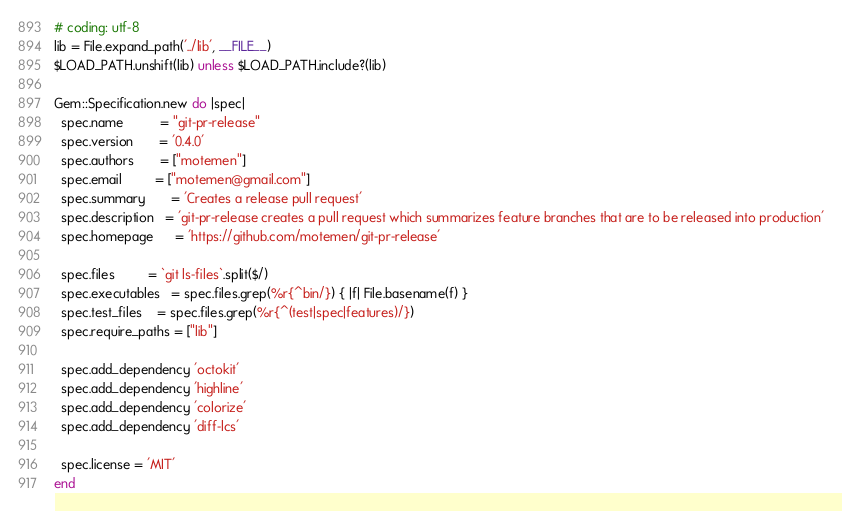<code> <loc_0><loc_0><loc_500><loc_500><_Ruby_># coding: utf-8
lib = File.expand_path('../lib', __FILE__)
$LOAD_PATH.unshift(lib) unless $LOAD_PATH.include?(lib)

Gem::Specification.new do |spec|
  spec.name          = "git-pr-release"
  spec.version       = '0.4.0'
  spec.authors       = ["motemen"]
  spec.email         = ["motemen@gmail.com"]
  spec.summary       = 'Creates a release pull request'
  spec.description   = 'git-pr-release creates a pull request which summarizes feature branches that are to be released into production'
  spec.homepage      = 'https://github.com/motemen/git-pr-release'

  spec.files         = `git ls-files`.split($/)
  spec.executables   = spec.files.grep(%r{^bin/}) { |f| File.basename(f) }
  spec.test_files    = spec.files.grep(%r{^(test|spec|features)/})
  spec.require_paths = ["lib"]

  spec.add_dependency 'octokit'
  spec.add_dependency 'highline'
  spec.add_dependency 'colorize'
  spec.add_dependency 'diff-lcs'

  spec.license = 'MIT'
end
</code> 